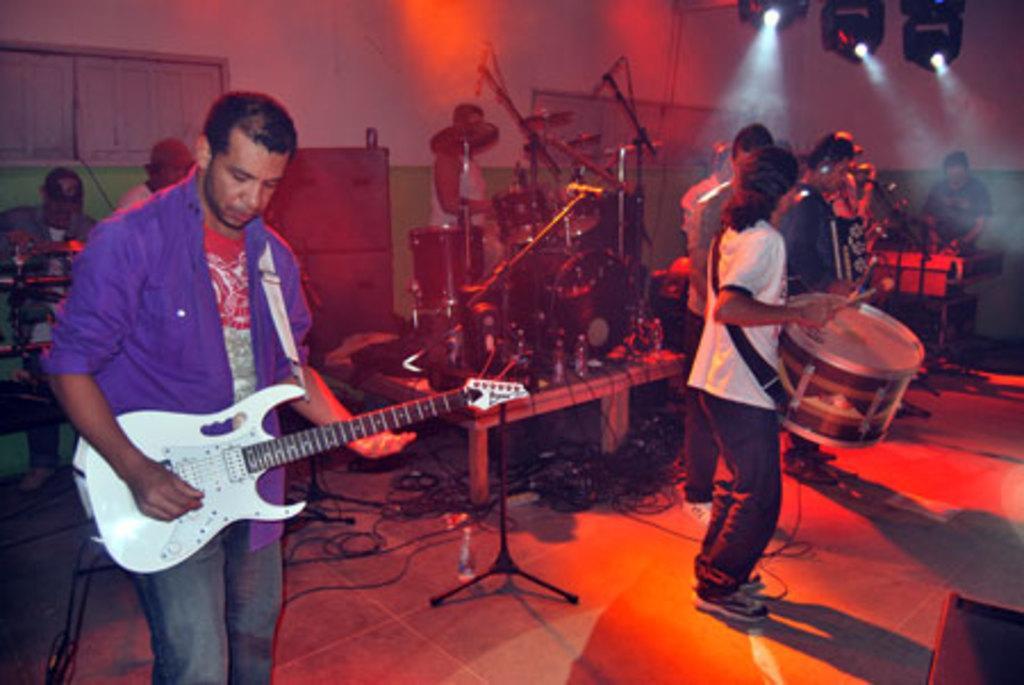Describe this image in one or two sentences. In the picture, it is a music show a person wearing violet color shirt is playing guitar right side to him there are few other people who are playing drums, some are singing songs. Behind them there is another person who is playing drums with huge musical instrument, in the background there is a wall white and green color there are also lights inside the room. 